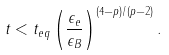Convert formula to latex. <formula><loc_0><loc_0><loc_500><loc_500>t < t _ { e q } \left ( \frac { \epsilon _ { e } } { \epsilon _ { B } } \right ) ^ { ( 4 - p ) / ( p - 2 ) } .</formula> 